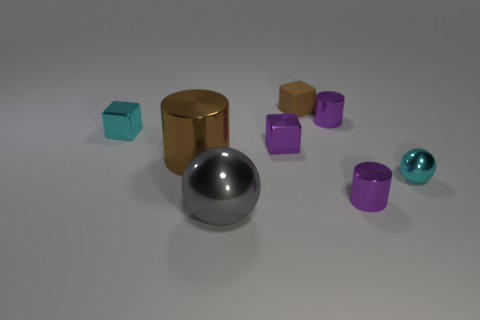Subtract all cubes. How many objects are left? 5 Add 8 gray metal balls. How many gray metal balls exist? 9 Subtract 1 purple cubes. How many objects are left? 7 Subtract all big brown shiny cylinders. Subtract all tiny cyan metallic spheres. How many objects are left? 6 Add 8 brown metal things. How many brown metal things are left? 9 